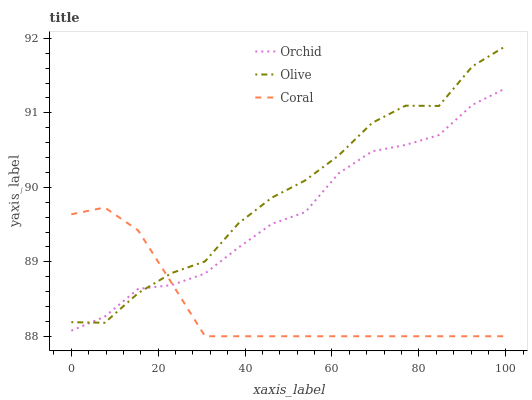Does Coral have the minimum area under the curve?
Answer yes or no. Yes. Does Olive have the maximum area under the curve?
Answer yes or no. Yes. Does Orchid have the minimum area under the curve?
Answer yes or no. No. Does Orchid have the maximum area under the curve?
Answer yes or no. No. Is Coral the smoothest?
Answer yes or no. Yes. Is Olive the roughest?
Answer yes or no. Yes. Is Orchid the smoothest?
Answer yes or no. No. Is Orchid the roughest?
Answer yes or no. No. Does Orchid have the lowest value?
Answer yes or no. No. Does Orchid have the highest value?
Answer yes or no. No. 